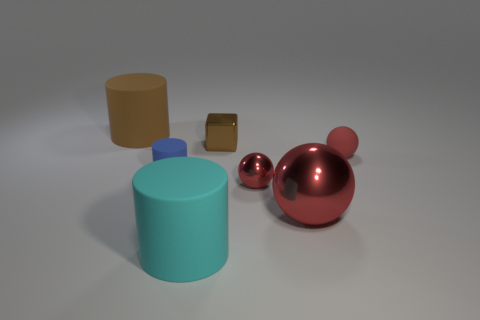Is there a small rubber ball that has the same color as the small metallic block? no 